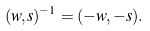Convert formula to latex. <formula><loc_0><loc_0><loc_500><loc_500>( w , s ) ^ { - 1 } = ( - w , - s ) .</formula> 